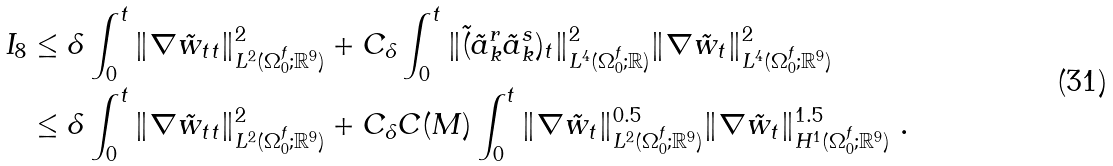<formula> <loc_0><loc_0><loc_500><loc_500>I _ { 8 } & \leq \delta \int _ { 0 } ^ { t } \| \nabla \tilde { w } _ { t t } \| ^ { 2 } _ { L ^ { 2 } ( \Omega _ { 0 } ^ { f } ; { \mathbb { R } } ^ { 9 } ) } + C _ { \delta } \int _ { 0 } ^ { t } \| \tilde { ( } \tilde { a } _ { k } ^ { r } \tilde { a } _ { k } ^ { s } ) _ { t } \| ^ { 2 } _ { L ^ { 4 } ( \Omega _ { 0 } ^ { f } ; { \mathbb { R } } ) } \| \nabla \tilde { w } _ { t } \| ^ { 2 } _ { L ^ { 4 } ( \Omega _ { 0 } ^ { f } ; { \mathbb { R } } ^ { 9 } ) } \\ & \leq \delta \int _ { 0 } ^ { t } \| \nabla \tilde { w } _ { t t } \| ^ { 2 } _ { L ^ { 2 } ( \Omega _ { 0 } ^ { f } ; { \mathbb { R } } ^ { 9 } ) } + C _ { \delta } C ( M ) \int _ { 0 } ^ { t } \| \nabla \tilde { w } _ { t } \| ^ { 0 . 5 } _ { L ^ { 2 } ( \Omega _ { 0 } ^ { f } ; { \mathbb { R } } ^ { 9 } ) } \| \nabla \tilde { w } _ { t } \| ^ { 1 . 5 } _ { H ^ { 1 } ( \Omega _ { 0 } ^ { f } ; { \mathbb { R } } ^ { 9 } ) } \ .</formula> 